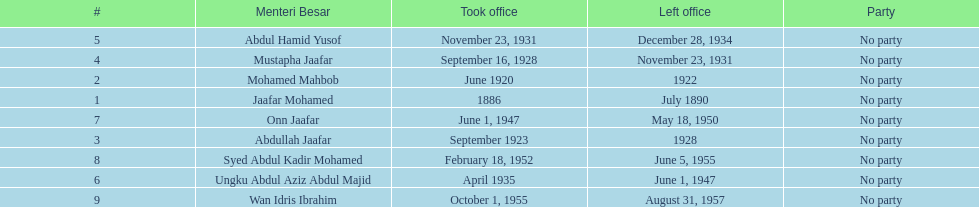Who was the first to take office? Jaafar Mohamed. 